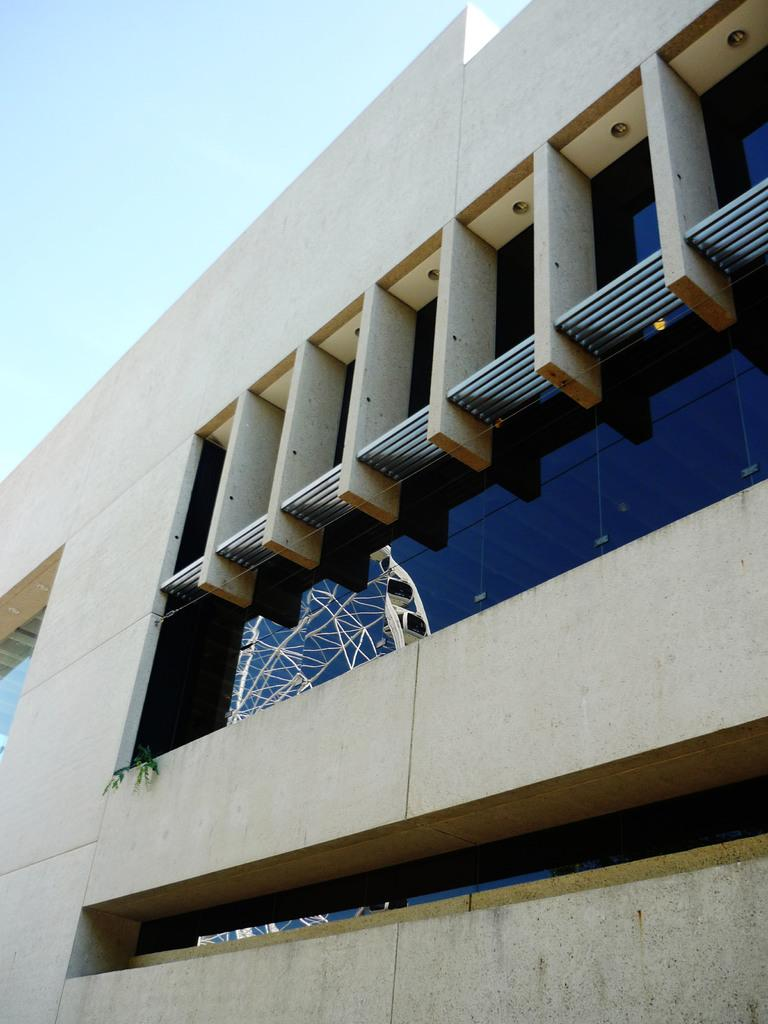What type of structure is in the image? There is a building in the image. What feature can be observed on the building? The building has glass windows. What do the glass windows reflect? The glass windows reflect a tower. What type of hair can be seen on the art piece in the image? There is no art piece or hair present in the image; it features a building with glass windows reflecting a tower. 